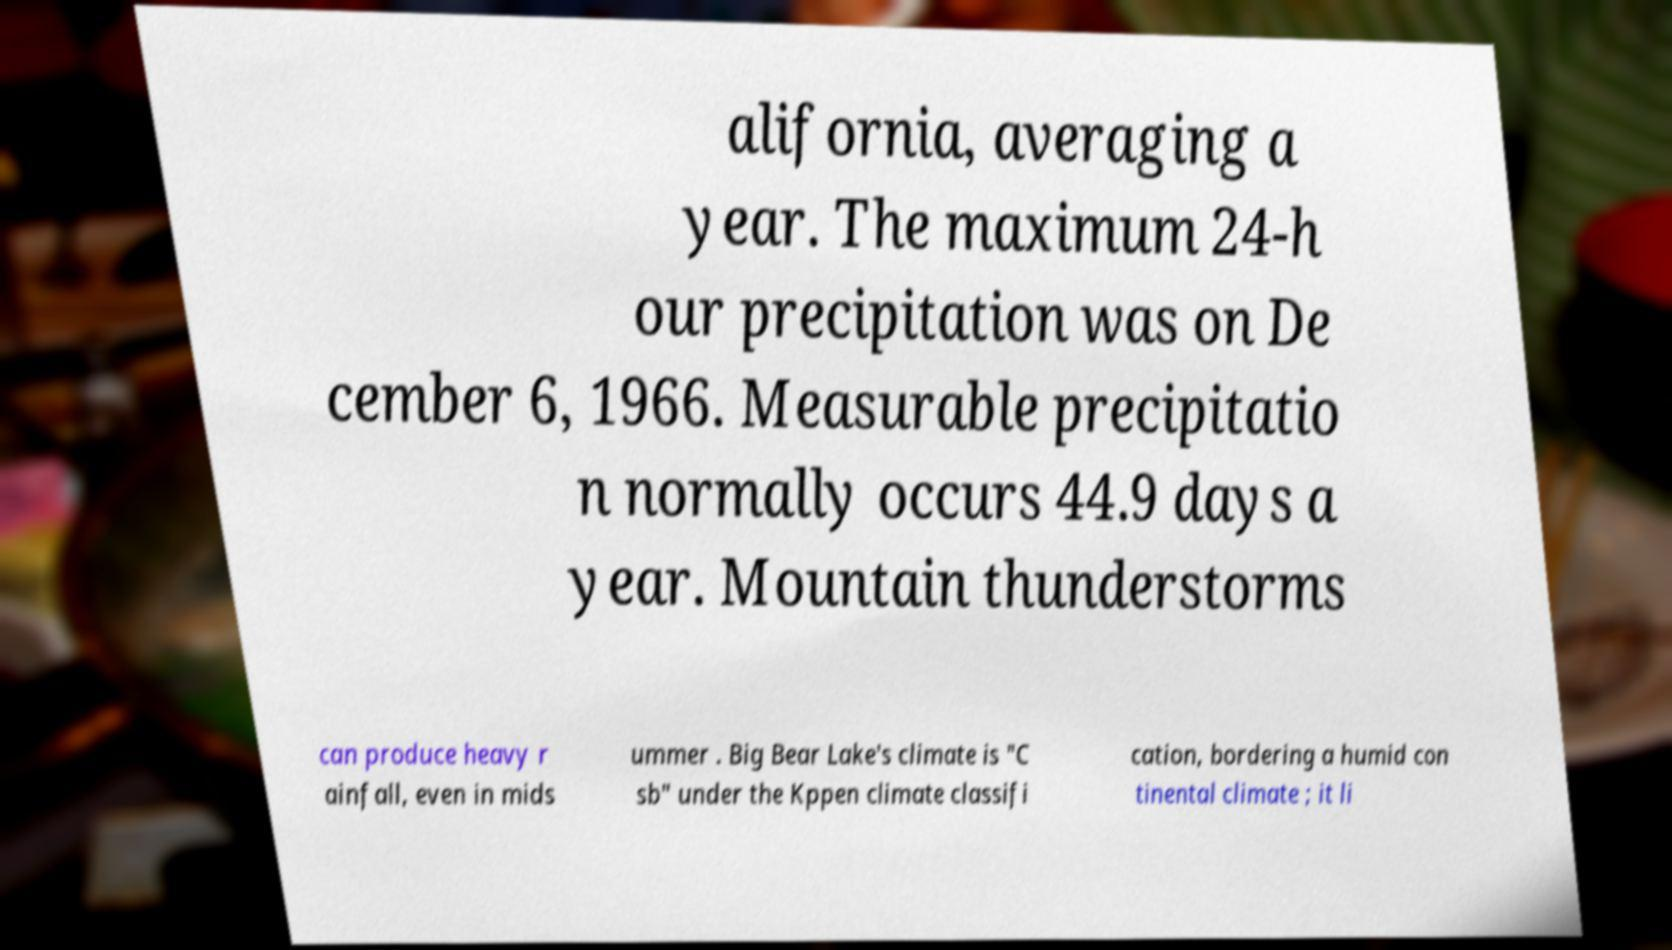Could you assist in decoding the text presented in this image and type it out clearly? alifornia, averaging a year. The maximum 24-h our precipitation was on De cember 6, 1966. Measurable precipitatio n normally occurs 44.9 days a year. Mountain thunderstorms can produce heavy r ainfall, even in mids ummer . Big Bear Lake's climate is "C sb" under the Kppen climate classifi cation, bordering a humid con tinental climate ; it li 